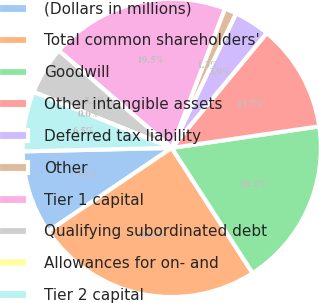<chart> <loc_0><loc_0><loc_500><loc_500><pie_chart><fcel>(Dollars in millions)<fcel>Total common shareholders'<fcel>Goodwill<fcel>Other intangible assets<fcel>Deferred tax liability<fcel>Other<fcel>Tier 1 capital<fcel>Qualifying subordinated debt<fcel>Allowances for on- and<fcel>Tier 2 capital<nl><fcel>9.09%<fcel>24.67%<fcel>18.18%<fcel>11.69%<fcel>3.9%<fcel>1.3%<fcel>19.48%<fcel>5.2%<fcel>0.0%<fcel>6.49%<nl></chart> 